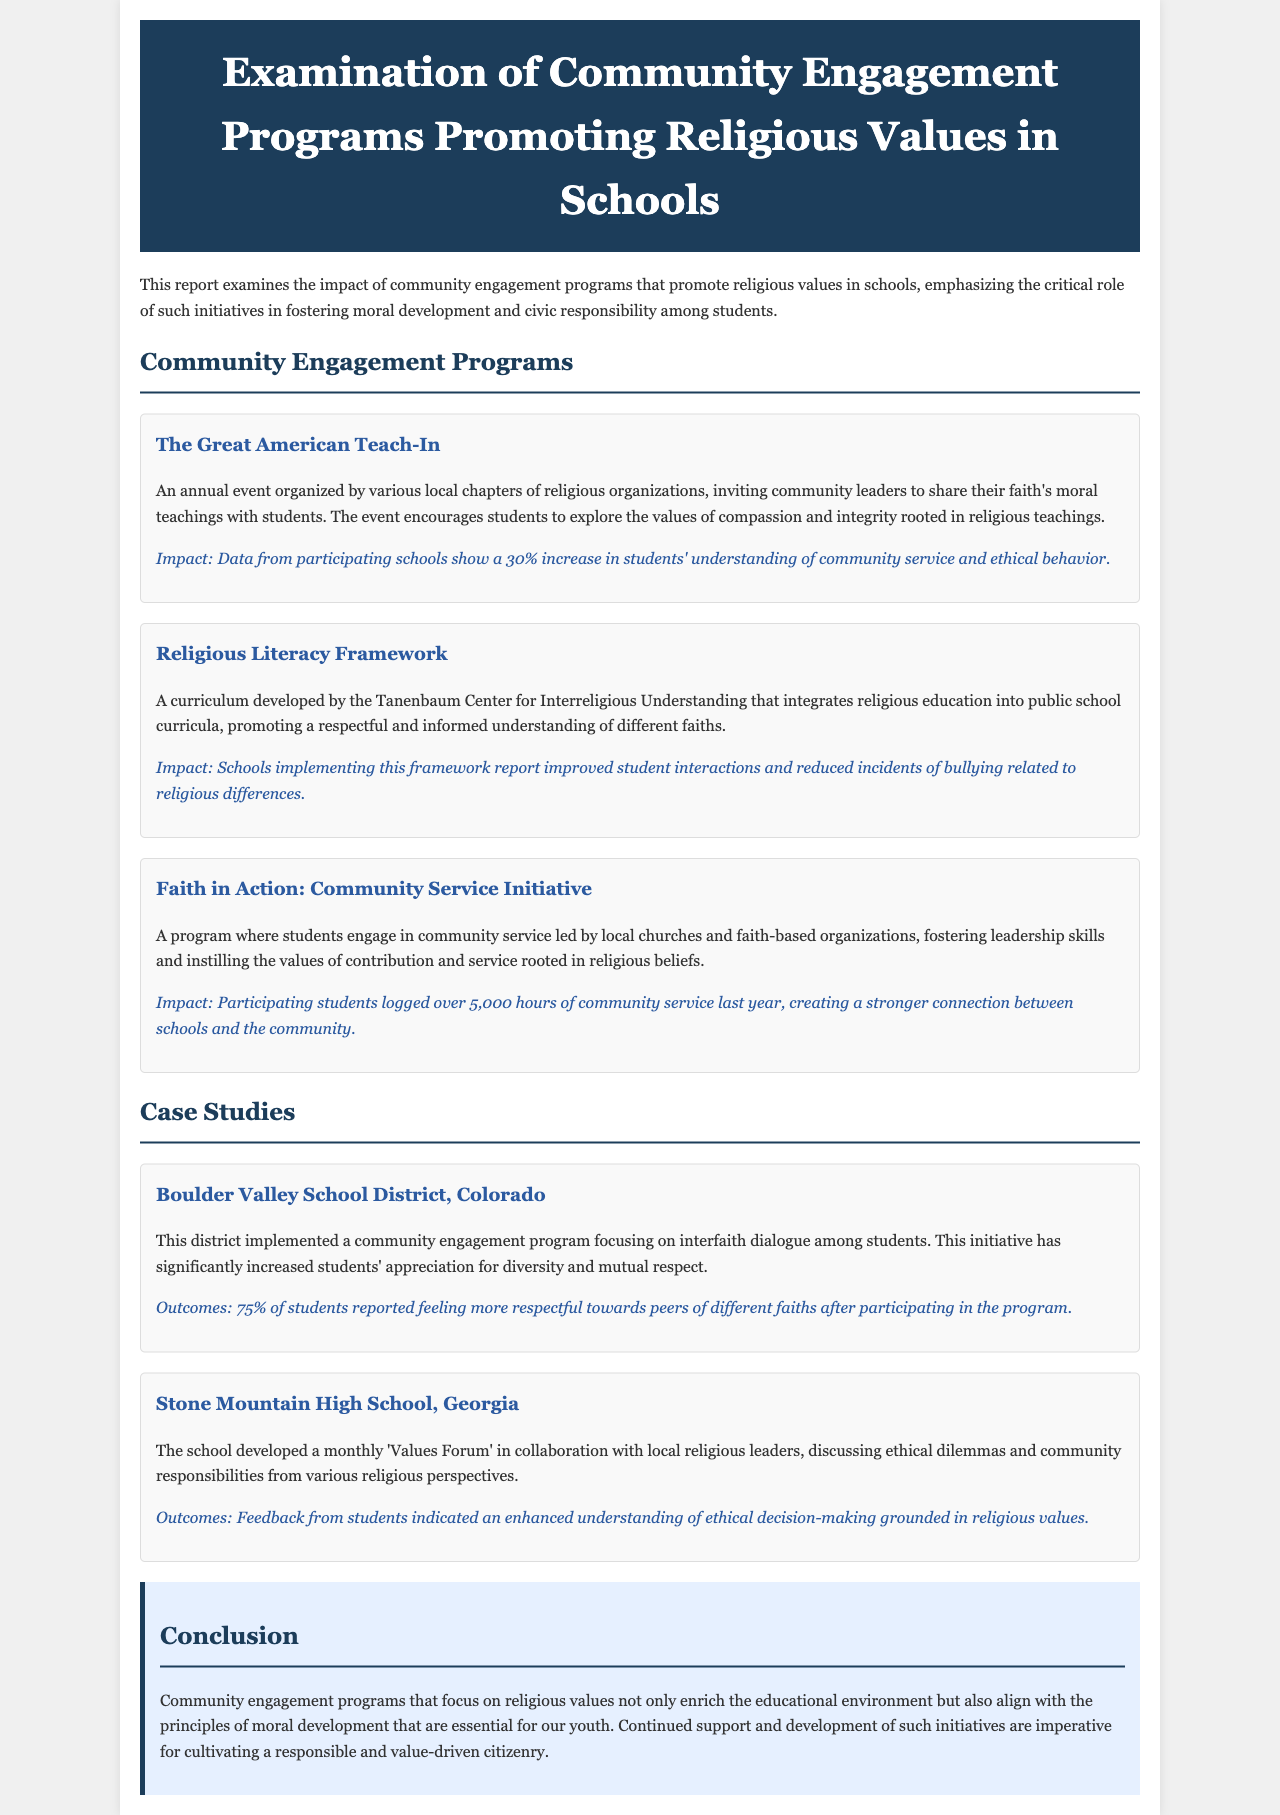What is the title of the report? The title is found at the top of the document.
Answer: Examination of Community Engagement Programs Promoting Religious Values in Schools What is the impact percentage of The Great American Teach-In? The impact percentage is stated in the section about the program.
Answer: 30% How many hours of community service did participating students log in the Faith in Action program? This information is provided in the description of the Faith in Action program.
Answer: over 5,000 hours What percentage of students in Boulder Valley School District reported feeling more respectful? The percentage is indicated in the outcomes of the case study.
Answer: 75% Which curriculum is mentioned in the document? The curriculum is described in the section on community engagement programs.
Answer: Religious Literacy Framework What type of program does Stone Mountain High School conduct? The program type is specified in the case study about the school.
Answer: Values Forum Which organization developed the Religious Literacy Framework? The organization is mentioned in the description of the framework.
Answer: Tanenbaum Center for Interreligious Understanding What is the main conclusion of the report? The conclusion is summarized in the final section of the document.
Answer: Continued support and development of such initiatives are imperative for cultivating a responsible and value-driven citizenry 